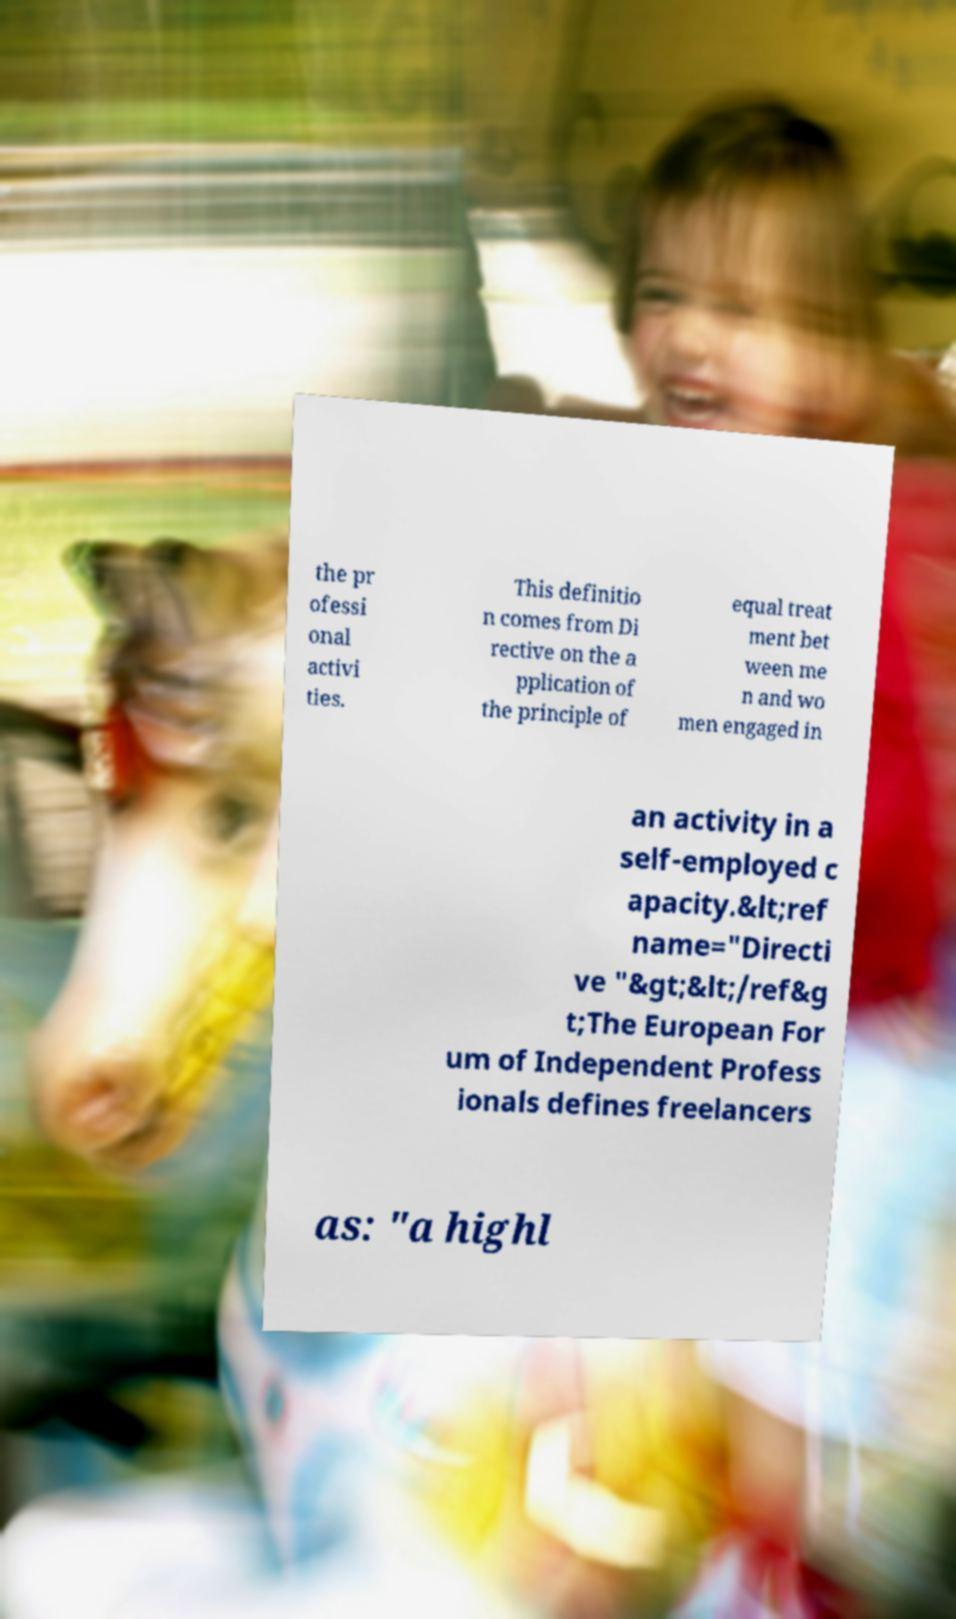Can you accurately transcribe the text from the provided image for me? the pr ofessi onal activi ties. This definitio n comes from Di rective on the a pplication of the principle of equal treat ment bet ween me n and wo men engaged in an activity in a self-employed c apacity.&lt;ref name="Directi ve "&gt;&lt;/ref&g t;The European For um of Independent Profess ionals defines freelancers as: "a highl 